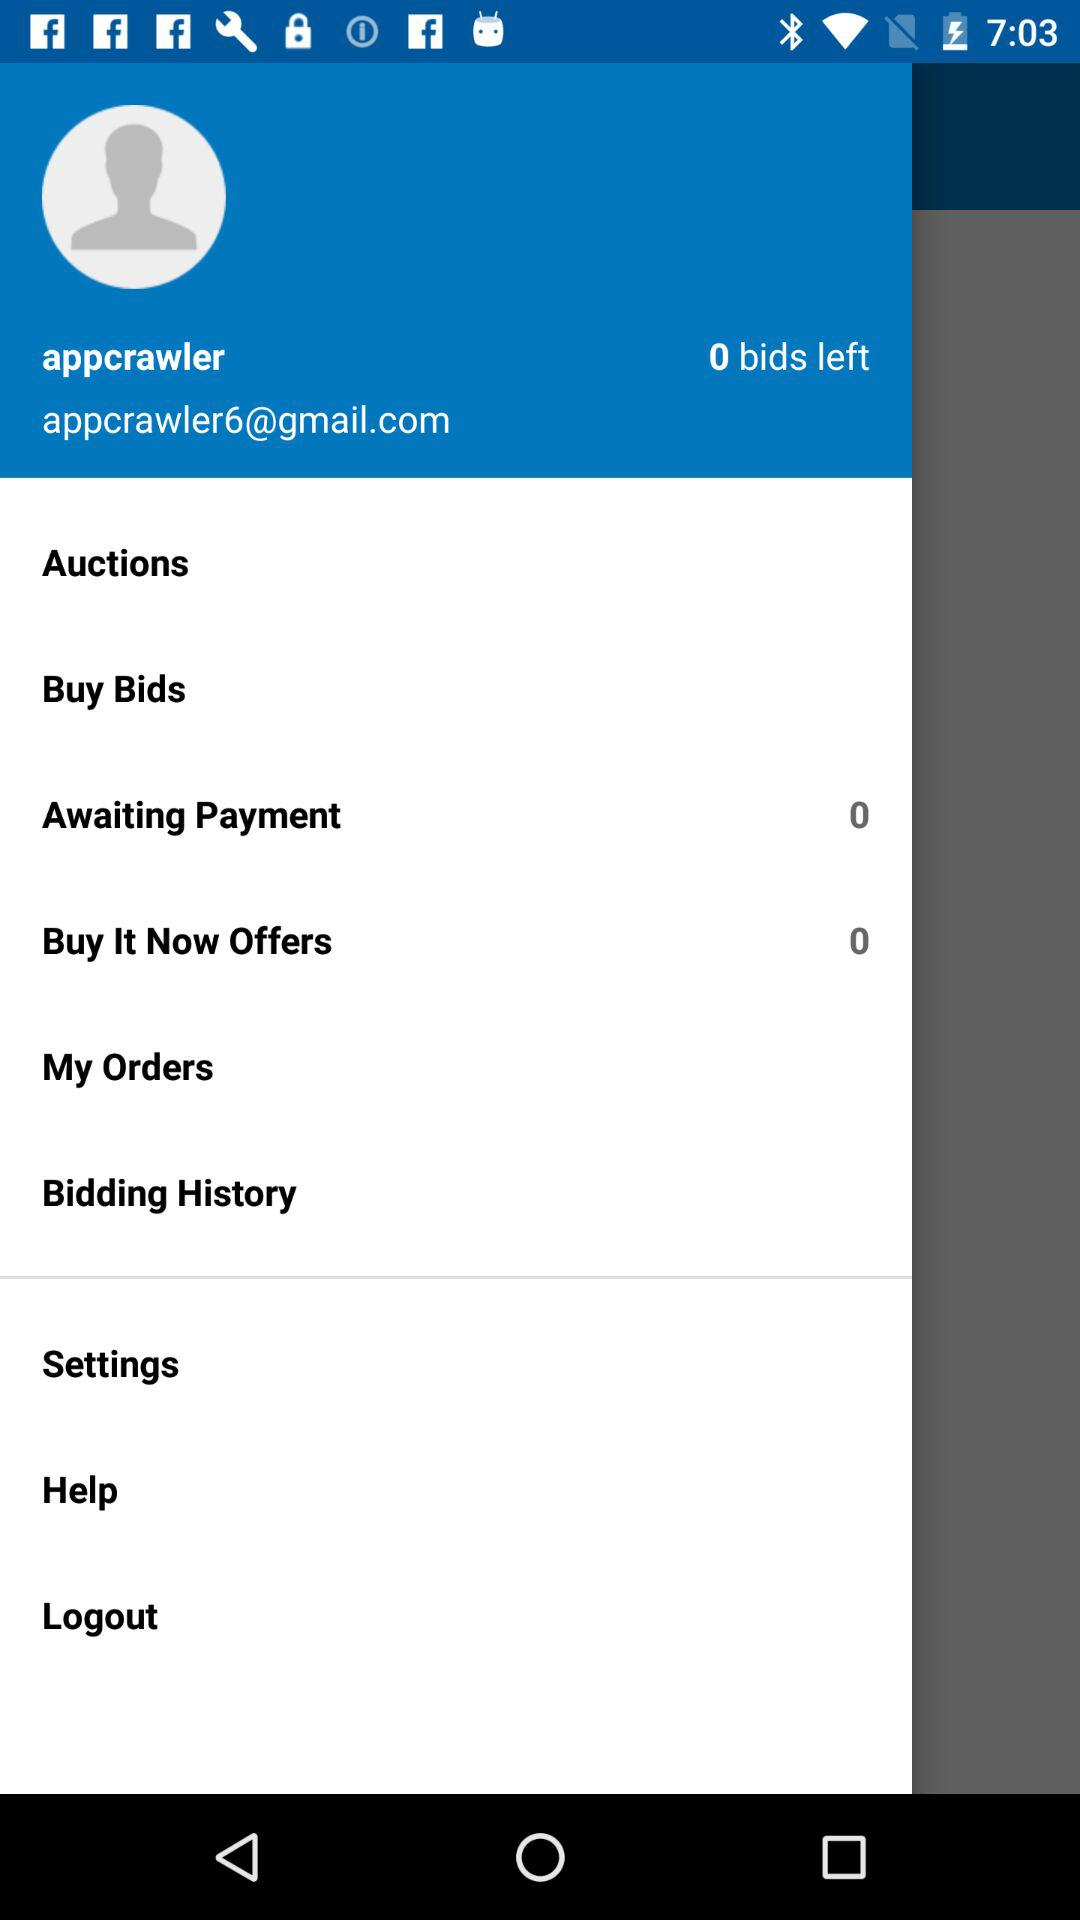What is the email address? The email address is "appcrawler6@gmail.com". 